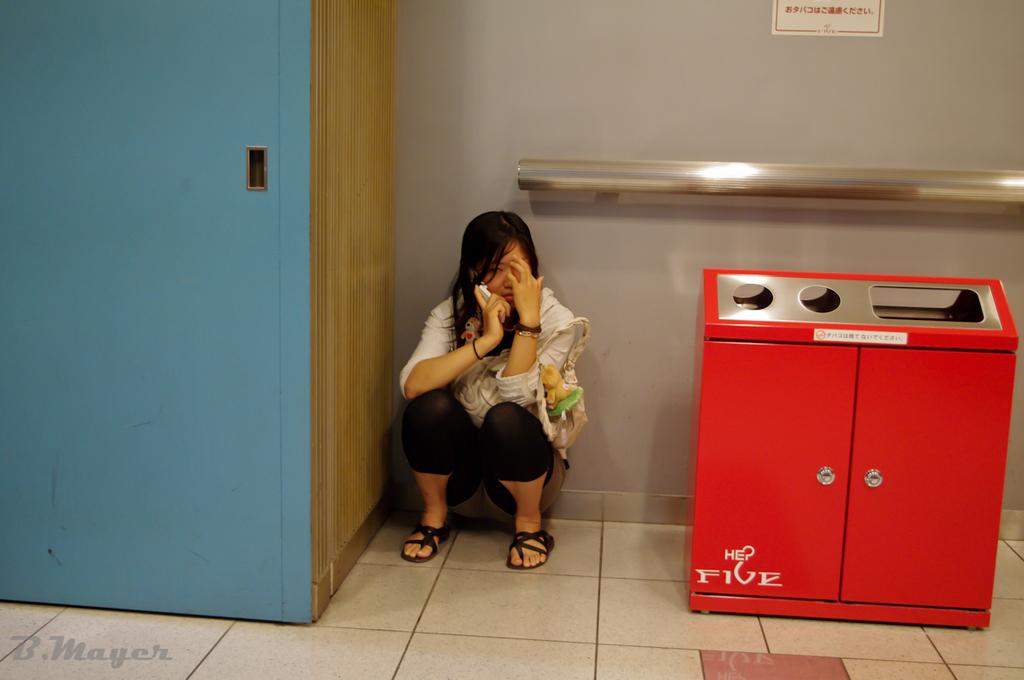What is the word written at the very bottom of the trash can?
Offer a terse response. Five. 